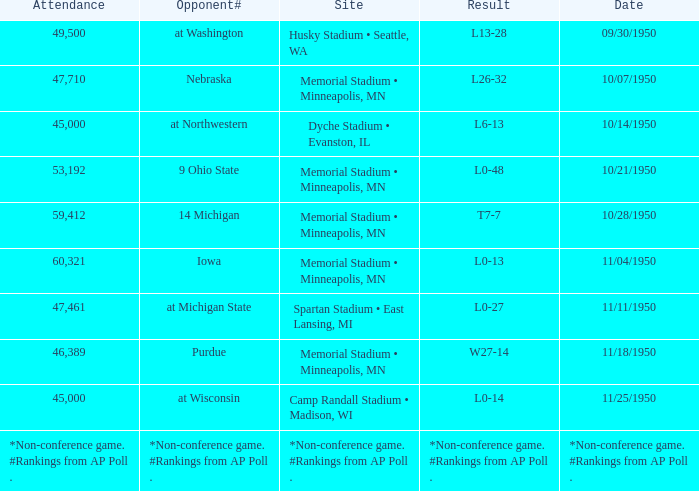What is the Site when the date is 11/11/1950? Spartan Stadium • East Lansing, MI. 